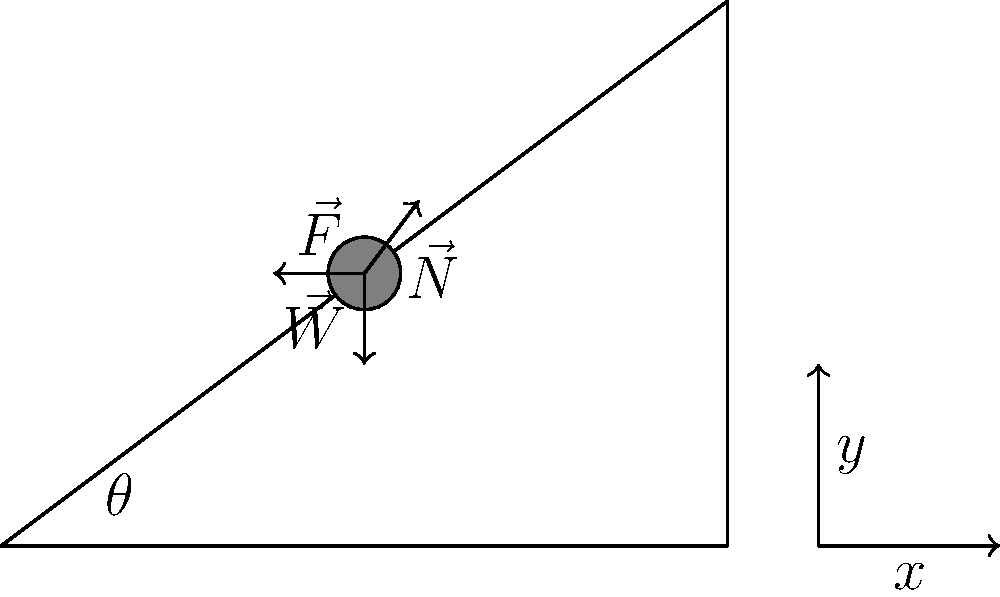A Baruch College physics graduate is designing a warehouse storage system with an inclined conveyor belt. The belt forms an angle $\theta$ with the horizontal, and a box of mass $m$ is placed on it. If the coefficient of static friction between the box and the belt is $\mu_s$, what is the maximum angle $\theta_{max}$ at which the box will remain stationary on the belt without sliding? Let's approach this step-by-step:

1) First, we identify the forces acting on the box:
   - Weight ($\vec{W}$) acting downward
   - Normal force ($\vec{N}$) perpendicular to the inclined surface
   - Static friction force ($\vec{F}$) acting up the incline

2) The weight can be broken into components:
   - Parallel to the incline: $W \sin \theta = mg \sin \theta$
   - Perpendicular to the incline: $W \cos \theta = mg \cos \theta$

3) For the box to remain stationary, the sum of forces along the incline must be zero:
   $F - mg \sin \theta = 0$

4) The maximum static friction is given by:
   $F_{max} = \mu_s N = \mu_s mg \cos \theta$

5) At the maximum angle, the friction force will be at its maximum. Substituting this into the equation from step 3:
   $\mu_s mg \cos \theta_{max} - mg \sin \theta_{max} = 0$

6) Dividing both sides by $mg$:
   $\mu_s \cos \theta_{max} = \sin \theta_{max}$

7) Dividing both sides by $\cos \theta_{max}$:
   $\mu_s = \tan \theta_{max}$

8) Therefore, the maximum angle is:
   $\theta_{max} = \arctan(\mu_s)$

This result shows that the maximum angle depends only on the coefficient of static friction, not on the mass of the box or the acceleration due to gravity.
Answer: $\theta_{max} = \arctan(\mu_s)$ 